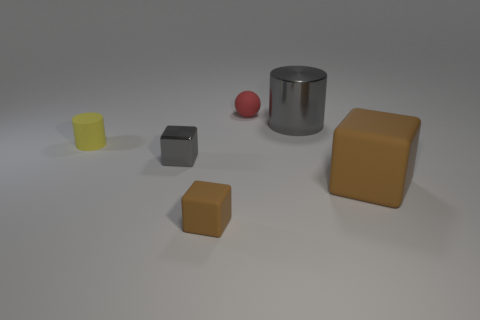There is another gray thing that is the same material as the small gray thing; what is its size?
Provide a succinct answer. Large. What size is the metal thing that is the same color as the large metallic cylinder?
Your answer should be very brief. Small. Does the shiny cube have the same color as the large matte block?
Ensure brevity in your answer.  No. Is there a matte object that is left of the brown rubber thing that is in front of the large brown block in front of the tiny cylinder?
Offer a very short reply. Yes. What number of other things have the same size as the red thing?
Make the answer very short. 3. Do the cylinder to the left of the small brown block and the thing that is in front of the large rubber object have the same size?
Offer a terse response. Yes. There is a matte thing that is both behind the large block and in front of the red thing; what is its shape?
Ensure brevity in your answer.  Cylinder. Is there a small matte cylinder of the same color as the tiny ball?
Offer a terse response. No. Is there a gray object?
Your answer should be very brief. Yes. The cylinder that is to the right of the tiny yellow thing is what color?
Your answer should be very brief. Gray. 